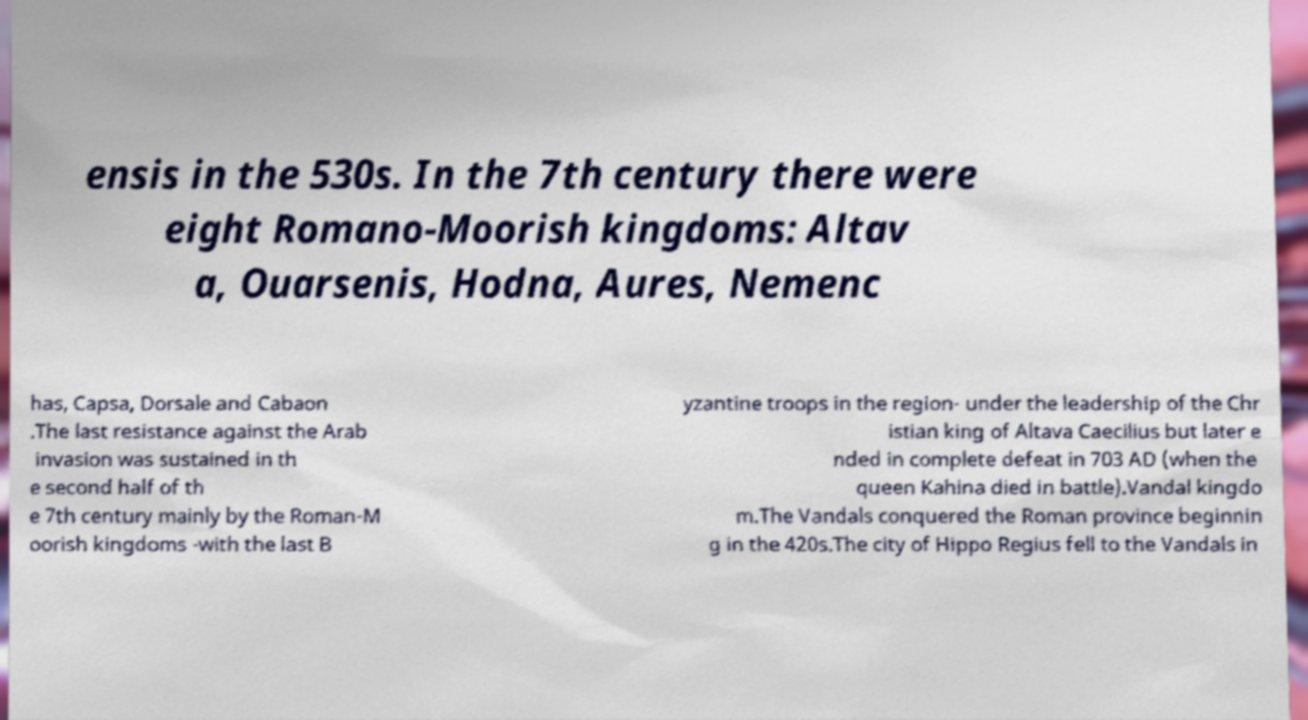For documentation purposes, I need the text within this image transcribed. Could you provide that? ensis in the 530s. In the 7th century there were eight Romano-Moorish kingdoms: Altav a, Ouarsenis, Hodna, Aures, Nemenc has, Capsa, Dorsale and Cabaon .The last resistance against the Arab invasion was sustained in th e second half of th e 7th century mainly by the Roman-M oorish kingdoms -with the last B yzantine troops in the region- under the leadership of the Chr istian king of Altava Caecilius but later e nded in complete defeat in 703 AD (when the queen Kahina died in battle).Vandal kingdo m.The Vandals conquered the Roman province beginnin g in the 420s.The city of Hippo Regius fell to the Vandals in 